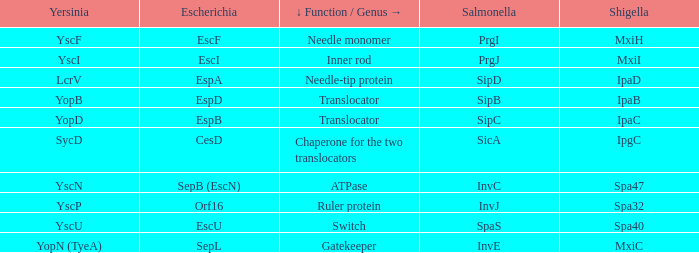Tell me the shigella and yscn Spa47. 